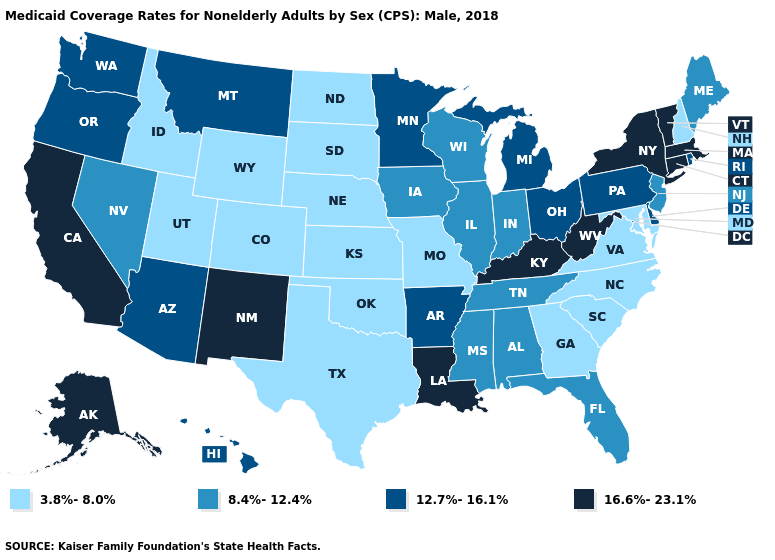Does Vermont have the lowest value in the USA?
Keep it brief. No. Name the states that have a value in the range 8.4%-12.4%?
Be succinct. Alabama, Florida, Illinois, Indiana, Iowa, Maine, Mississippi, Nevada, New Jersey, Tennessee, Wisconsin. What is the highest value in the USA?
Concise answer only. 16.6%-23.1%. Name the states that have a value in the range 12.7%-16.1%?
Quick response, please. Arizona, Arkansas, Delaware, Hawaii, Michigan, Minnesota, Montana, Ohio, Oregon, Pennsylvania, Rhode Island, Washington. Name the states that have a value in the range 12.7%-16.1%?
Be succinct. Arizona, Arkansas, Delaware, Hawaii, Michigan, Minnesota, Montana, Ohio, Oregon, Pennsylvania, Rhode Island, Washington. Which states hav the highest value in the Northeast?
Short answer required. Connecticut, Massachusetts, New York, Vermont. What is the lowest value in the Northeast?
Concise answer only. 3.8%-8.0%. What is the value of Louisiana?
Write a very short answer. 16.6%-23.1%. Which states hav the highest value in the MidWest?
Concise answer only. Michigan, Minnesota, Ohio. Name the states that have a value in the range 12.7%-16.1%?
Answer briefly. Arizona, Arkansas, Delaware, Hawaii, Michigan, Minnesota, Montana, Ohio, Oregon, Pennsylvania, Rhode Island, Washington. What is the value of Minnesota?
Concise answer only. 12.7%-16.1%. Does Idaho have the same value as Utah?
Be succinct. Yes. What is the value of South Carolina?
Write a very short answer. 3.8%-8.0%. What is the value of Virginia?
Write a very short answer. 3.8%-8.0%. What is the highest value in the USA?
Keep it brief. 16.6%-23.1%. 